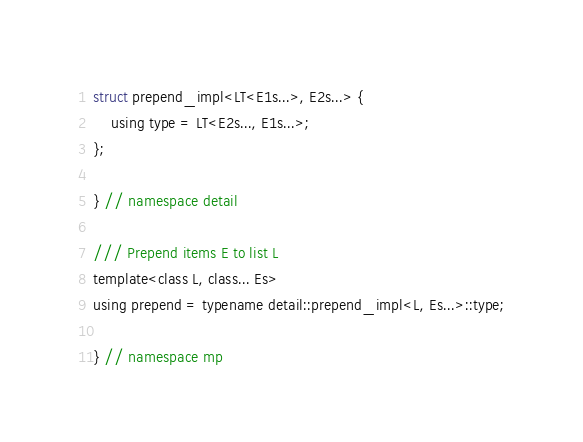Convert code to text. <code><loc_0><loc_0><loc_500><loc_500><_C_>struct prepend_impl<LT<E1s...>, E2s...> {
    using type = LT<E2s..., E1s...>;
};

} // namespace detail

/// Prepend items E to list L
template<class L, class... Es>
using prepend = typename detail::prepend_impl<L, Es...>::type;

} // namespace mp
</code> 